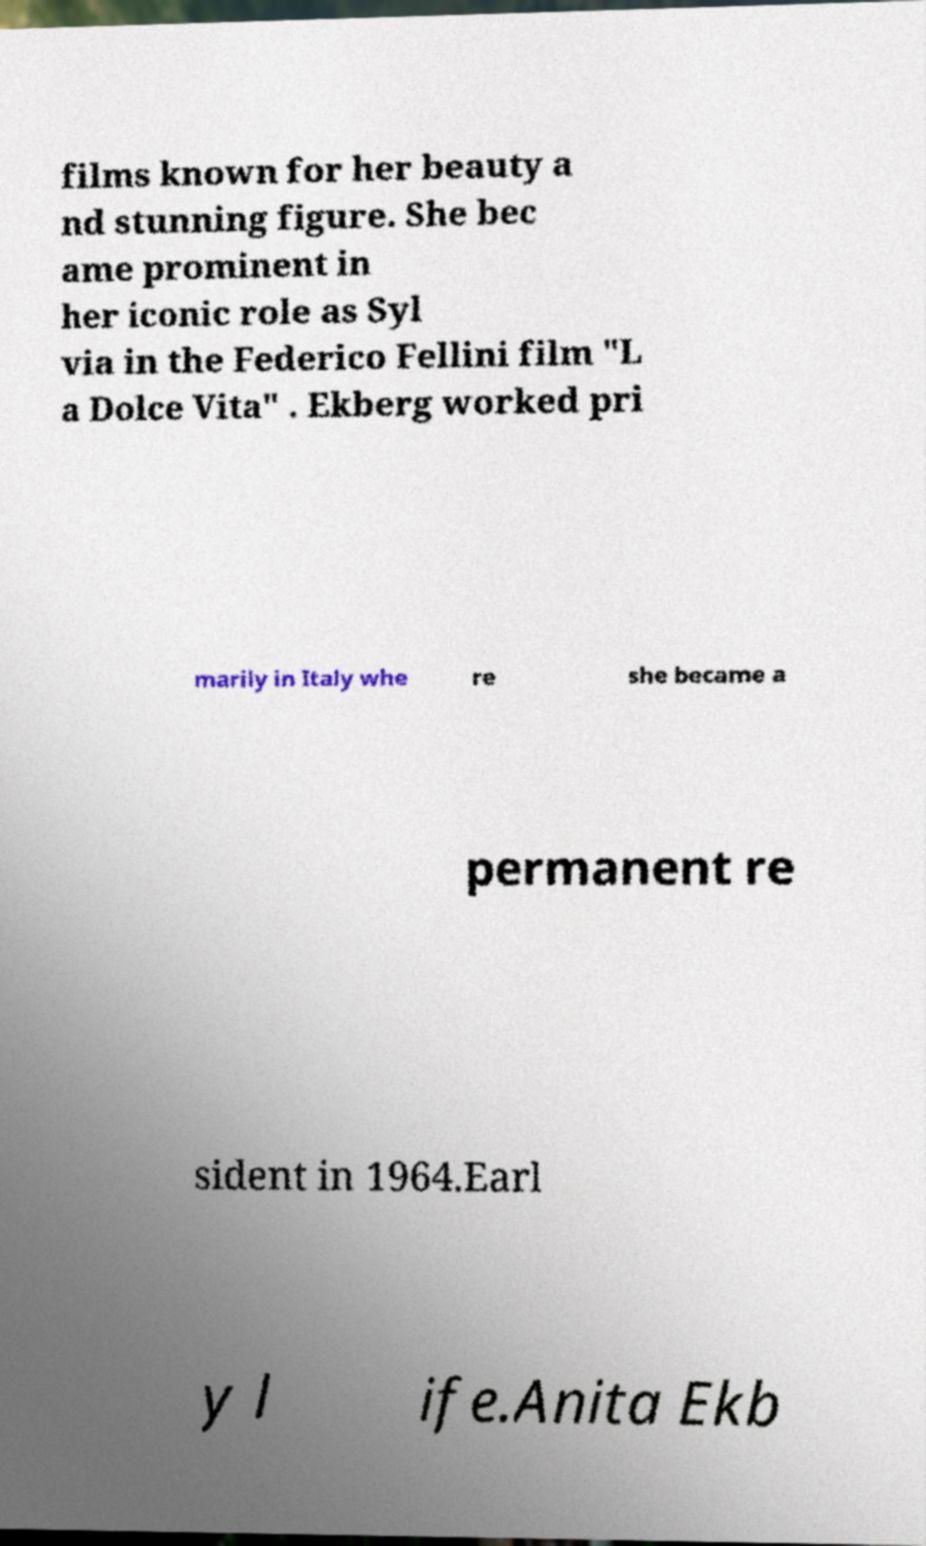Please read and relay the text visible in this image. What does it say? films known for her beauty a nd stunning figure. She bec ame prominent in her iconic role as Syl via in the Federico Fellini film "L a Dolce Vita" . Ekberg worked pri marily in Italy whe re she became a permanent re sident in 1964.Earl y l ife.Anita Ekb 